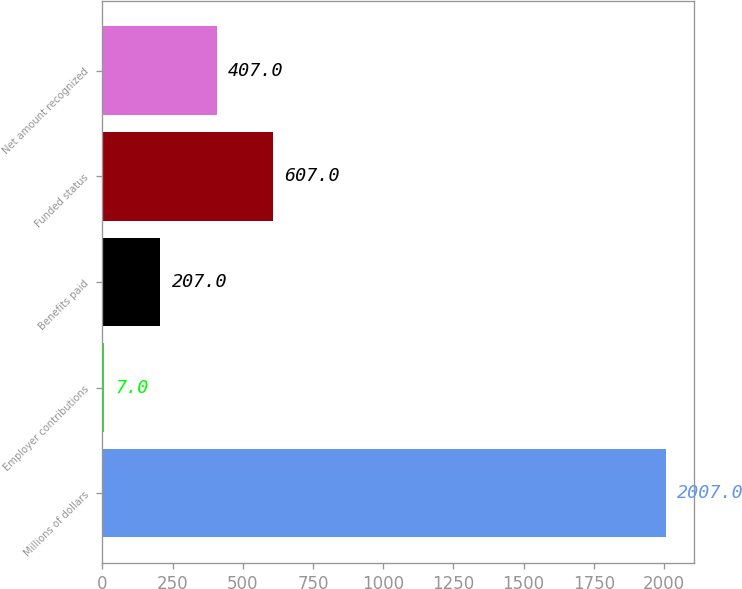<chart> <loc_0><loc_0><loc_500><loc_500><bar_chart><fcel>Millions of dollars<fcel>Employer contributions<fcel>Benefits paid<fcel>Funded status<fcel>Net amount recognized<nl><fcel>2007<fcel>7<fcel>207<fcel>607<fcel>407<nl></chart> 